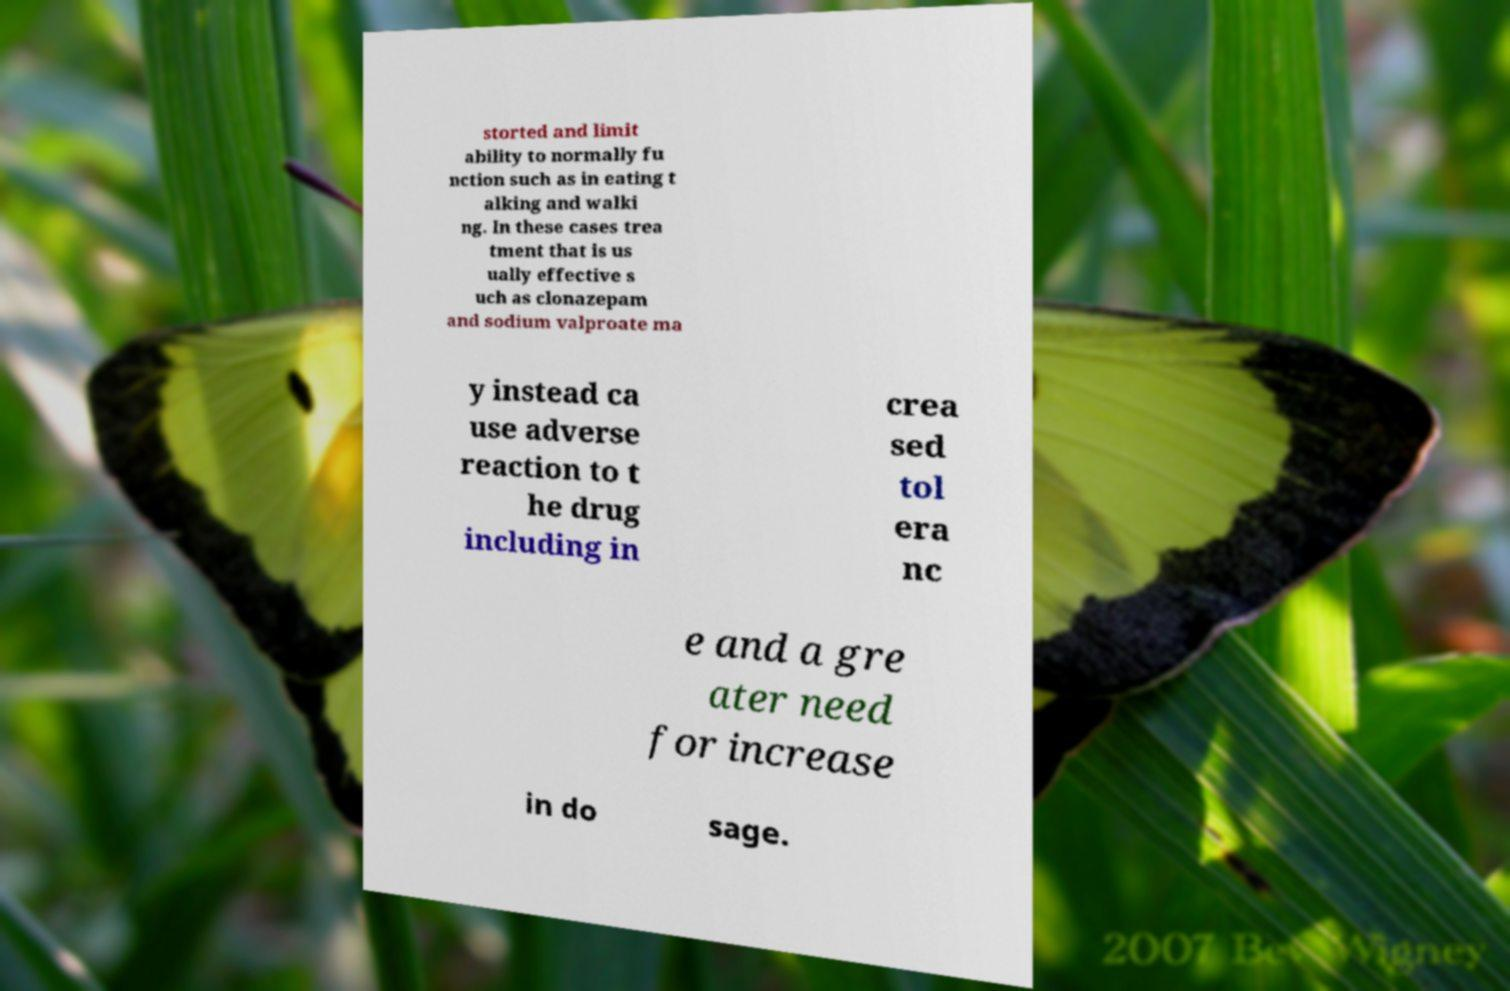Please read and relay the text visible in this image. What does it say? storted and limit ability to normally fu nction such as in eating t alking and walki ng. In these cases trea tment that is us ually effective s uch as clonazepam and sodium valproate ma y instead ca use adverse reaction to t he drug including in crea sed tol era nc e and a gre ater need for increase in do sage. 